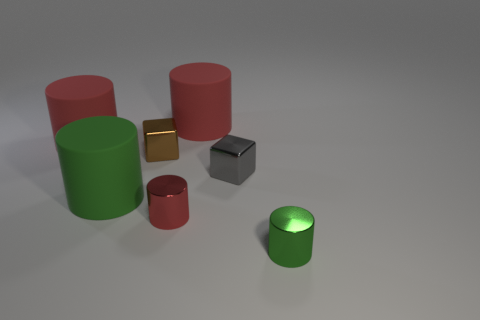What number of spheres are large matte things or brown shiny objects?
Offer a terse response. 0. There is a green thing on the left side of the green metal cylinder; is its shape the same as the small brown thing?
Your answer should be compact. No. Is the number of big matte objects that are on the left side of the red metallic object greater than the number of tiny cyan metal spheres?
Offer a very short reply. Yes. There is a cube that is the same size as the brown object; what is its color?
Your answer should be very brief. Gray. What number of objects are shiny cylinders that are right of the tiny red cylinder or small metal things?
Provide a succinct answer. 4. What is the material of the big red cylinder that is to the left of the large green cylinder to the left of the small brown thing?
Offer a very short reply. Rubber. Are there any small gray things that have the same material as the gray block?
Keep it short and to the point. No. Is there a small red object behind the metal block behind the gray metal object?
Ensure brevity in your answer.  No. There is a brown block behind the large green object; what is it made of?
Your answer should be very brief. Metal. Does the small gray object have the same shape as the small red object?
Offer a terse response. No. 